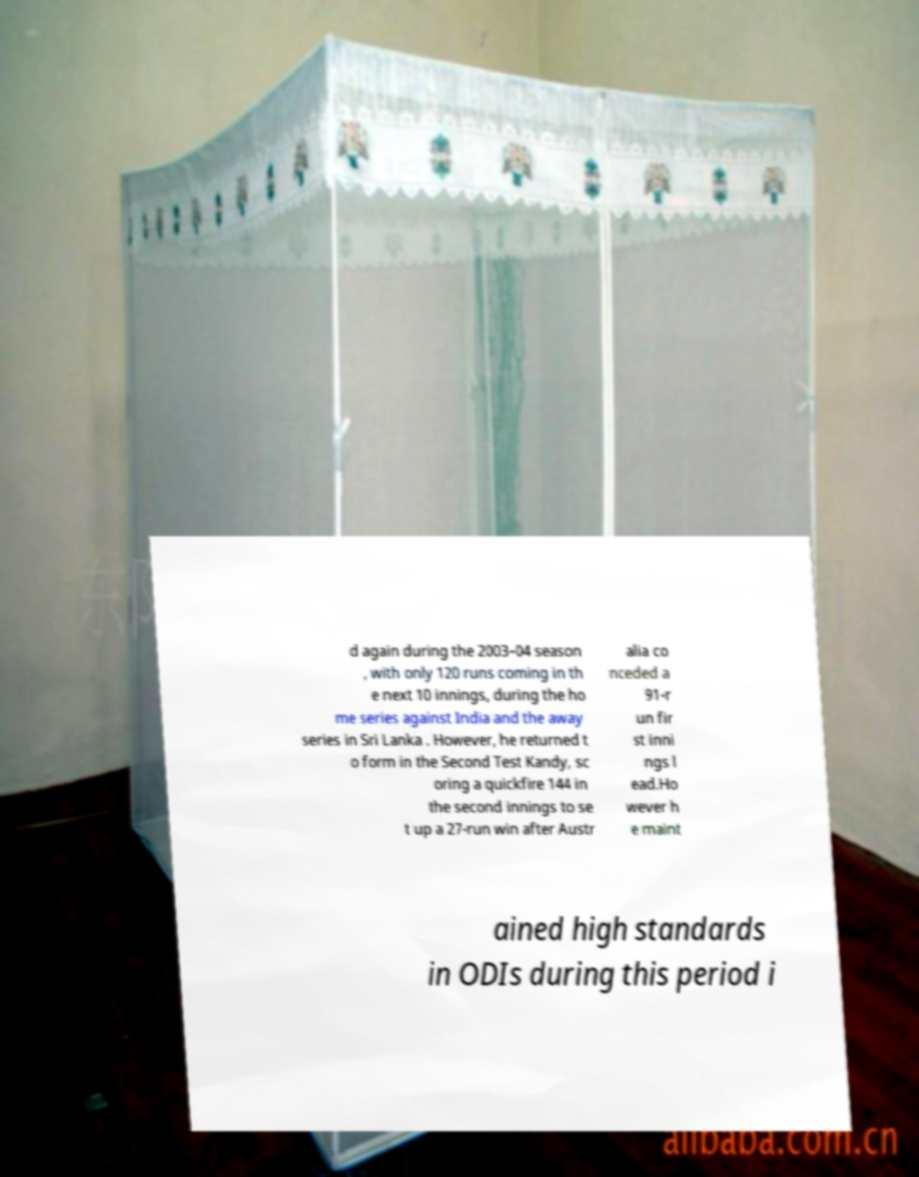Please read and relay the text visible in this image. What does it say? d again during the 2003–04 season , with only 120 runs coming in th e next 10 innings, during the ho me series against India and the away series in Sri Lanka . However, he returned t o form in the Second Test Kandy, sc oring a quickfire 144 in the second innings to se t up a 27-run win after Austr alia co nceded a 91-r un fir st inni ngs l ead.Ho wever h e maint ained high standards in ODIs during this period i 